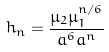<formula> <loc_0><loc_0><loc_500><loc_500>h _ { n } = \frac { \mu _ { 2 } \mu _ { 1 } ^ { n / 6 } } { a ^ { 6 } a ^ { n } }</formula> 